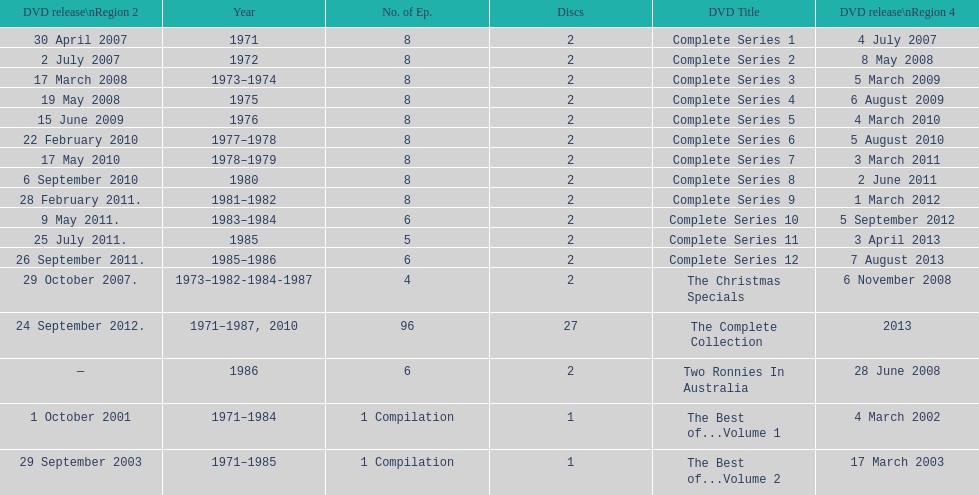The complete collection has 96 episodes, but the christmas specials only has how many episodes? 4. 